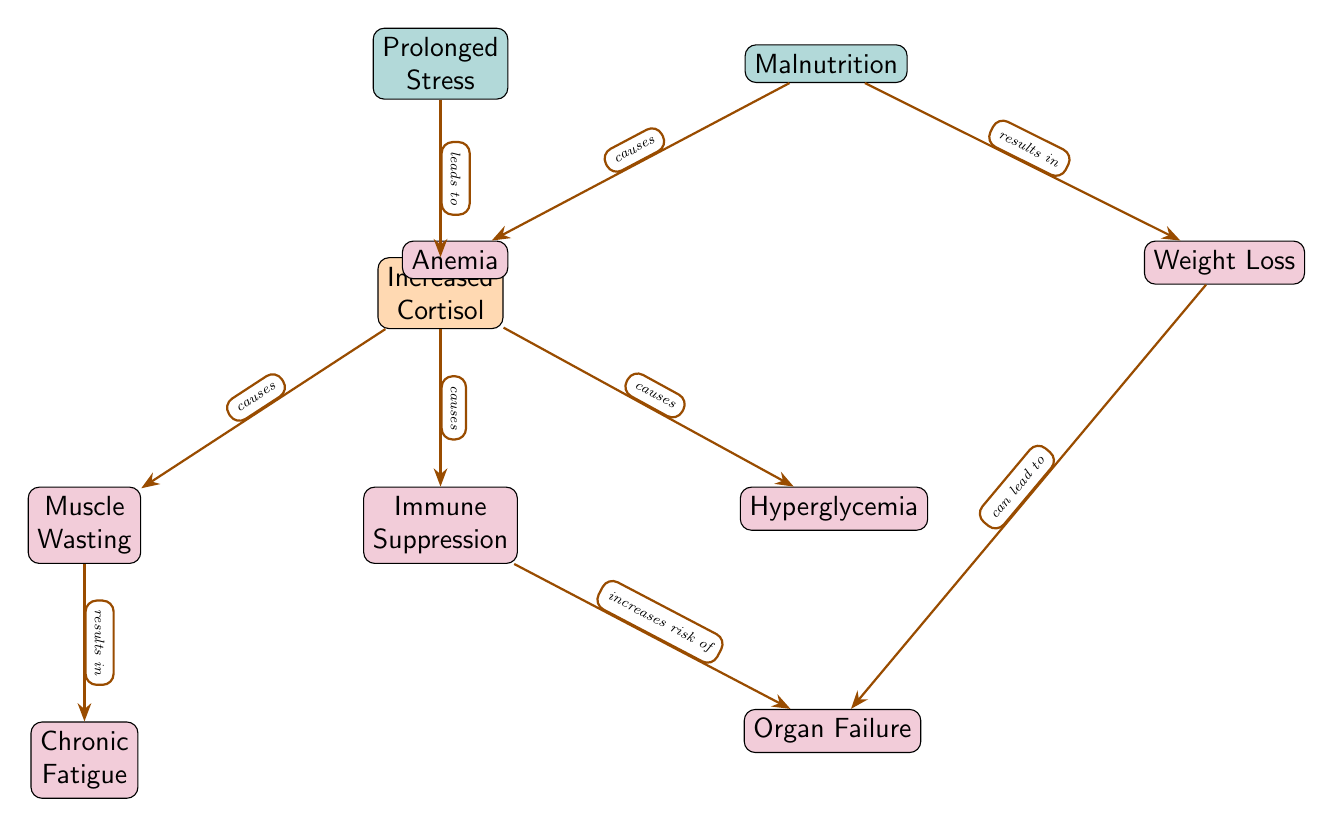What are the two primary factors depicted in the diagram? The diagram shows two primary factors at the top: "Prolonged Stress" and "Malnutrition". These are the initial causes that lead to various physiological changes.
Answer: Prolonged Stress, Malnutrition How many effects are caused by increased cortisol? The diagram illustrates that "Increased Cortisol" leads to three effects: "Muscle Wasting", "Immune Suppression", and "Hyperglycemia". Therefore, the count is three effects.
Answer: 3 What condition can result from muscle wasting? The diagram indicates that "Muscle Wasting" results in "Chronic Fatigue". It is a direct consequence of muscle depletion.
Answer: Chronic Fatigue What effect of malnutrition is indicated in the diagram? The diagram shows that "Malnutrition" causes "Anemia" as one of its direct physiological effects on the animal.
Answer: Anemia Which condition can lead to organ failure? According to the diagram, "Weight Loss" can lead to "Organ Failure". This means if the animal continues to lose weight, it increases the risk of experiencing organ failure.
Answer: Weight Loss What is the link between immune suppression and organ failure? The diagram states that "Immune Suppression" increases the risk of "Organ Failure". This connection suggests that a weakened immune system can negatively affect organ function.
Answer: Increases risk of What is the relationship between muscle wasting and fatigue? The diagram shows that "Muscle Wasting" directly causes "Chronic Fatigue", indicating that the loss of muscle leads to decreased energy and stamina.
Answer: Causes How many edges connect malnutrition to its consequences? In the diagram, "Malnutrition" has two edges leading to its consequences: "Anemia" and "Weight Loss". Each effect is linked directly from malnutrition.
Answer: 2 Which physiological change is not caused by prolonged stress? In the diagram, "Anemia" is the physiological change that is not caused by "Prolonged Stress". It is instead linked directly to "Malnutrition".
Answer: Anemia 